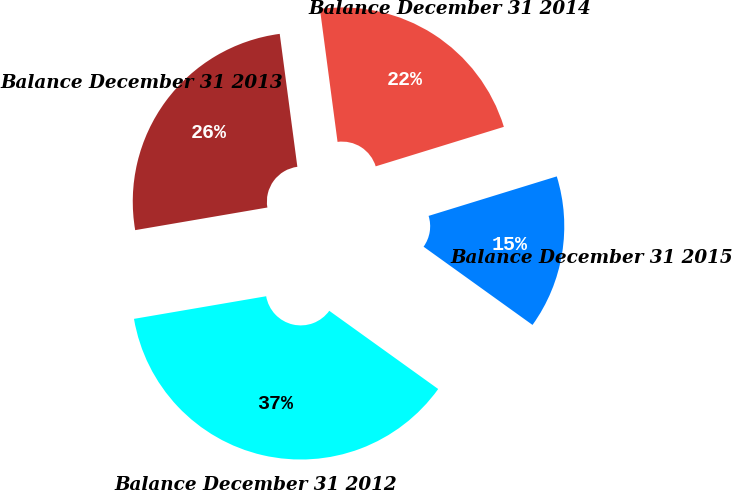<chart> <loc_0><loc_0><loc_500><loc_500><pie_chart><fcel>Balance December 31 2012<fcel>Balance December 31 2013<fcel>Balance December 31 2014<fcel>Balance December 31 2015<nl><fcel>37.39%<fcel>25.6%<fcel>22.34%<fcel>14.67%<nl></chart> 